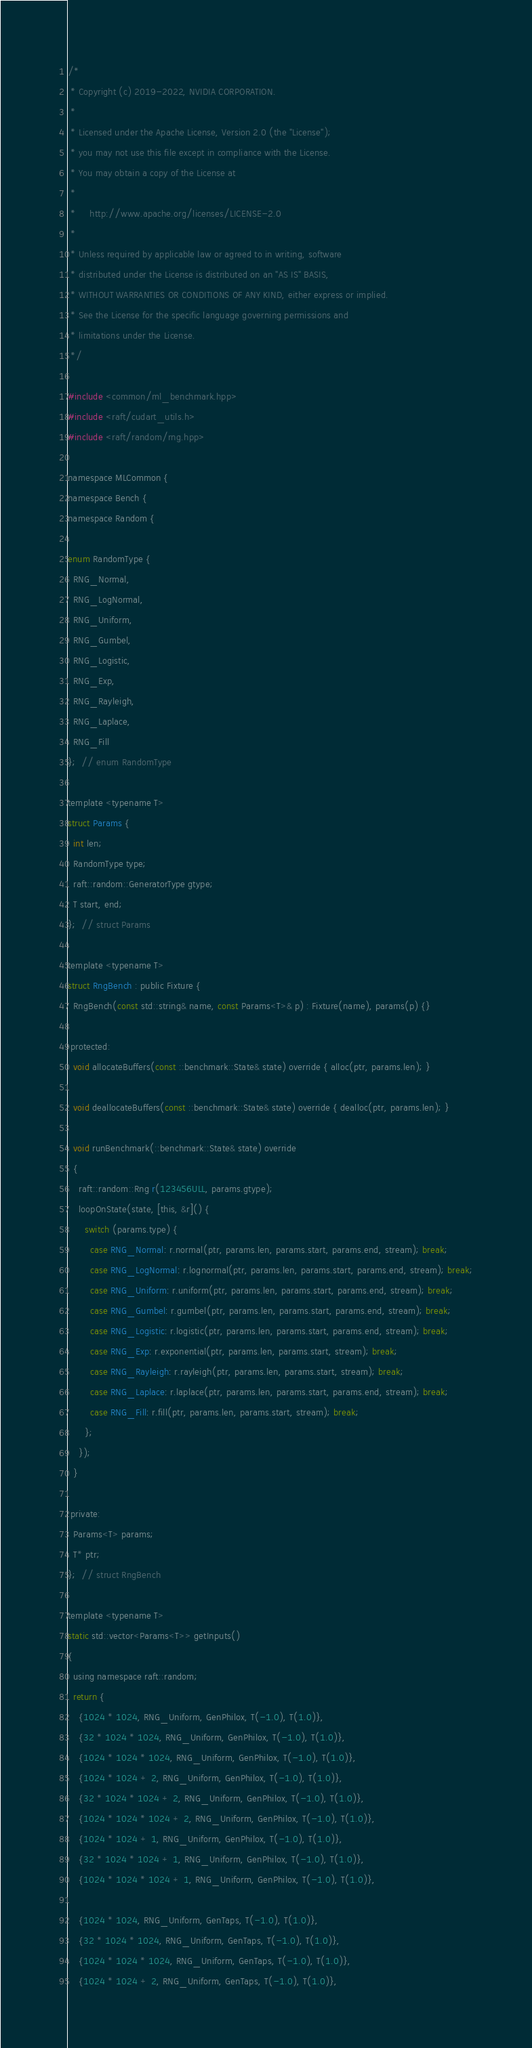<code> <loc_0><loc_0><loc_500><loc_500><_Cuda_>/*
 * Copyright (c) 2019-2022, NVIDIA CORPORATION.
 *
 * Licensed under the Apache License, Version 2.0 (the "License");
 * you may not use this file except in compliance with the License.
 * You may obtain a copy of the License at
 *
 *     http://www.apache.org/licenses/LICENSE-2.0
 *
 * Unless required by applicable law or agreed to in writing, software
 * distributed under the License is distributed on an "AS IS" BASIS,
 * WITHOUT WARRANTIES OR CONDITIONS OF ANY KIND, either express or implied.
 * See the License for the specific language governing permissions and
 * limitations under the License.
 */

#include <common/ml_benchmark.hpp>
#include <raft/cudart_utils.h>
#include <raft/random/rng.hpp>

namespace MLCommon {
namespace Bench {
namespace Random {

enum RandomType {
  RNG_Normal,
  RNG_LogNormal,
  RNG_Uniform,
  RNG_Gumbel,
  RNG_Logistic,
  RNG_Exp,
  RNG_Rayleigh,
  RNG_Laplace,
  RNG_Fill
};  // enum RandomType

template <typename T>
struct Params {
  int len;
  RandomType type;
  raft::random::GeneratorType gtype;
  T start, end;
};  // struct Params

template <typename T>
struct RngBench : public Fixture {
  RngBench(const std::string& name, const Params<T>& p) : Fixture(name), params(p) {}

 protected:
  void allocateBuffers(const ::benchmark::State& state) override { alloc(ptr, params.len); }

  void deallocateBuffers(const ::benchmark::State& state) override { dealloc(ptr, params.len); }

  void runBenchmark(::benchmark::State& state) override
  {
    raft::random::Rng r(123456ULL, params.gtype);
    loopOnState(state, [this, &r]() {
      switch (params.type) {
        case RNG_Normal: r.normal(ptr, params.len, params.start, params.end, stream); break;
        case RNG_LogNormal: r.lognormal(ptr, params.len, params.start, params.end, stream); break;
        case RNG_Uniform: r.uniform(ptr, params.len, params.start, params.end, stream); break;
        case RNG_Gumbel: r.gumbel(ptr, params.len, params.start, params.end, stream); break;
        case RNG_Logistic: r.logistic(ptr, params.len, params.start, params.end, stream); break;
        case RNG_Exp: r.exponential(ptr, params.len, params.start, stream); break;
        case RNG_Rayleigh: r.rayleigh(ptr, params.len, params.start, stream); break;
        case RNG_Laplace: r.laplace(ptr, params.len, params.start, params.end, stream); break;
        case RNG_Fill: r.fill(ptr, params.len, params.start, stream); break;
      };
    });
  }

 private:
  Params<T> params;
  T* ptr;
};  // struct RngBench

template <typename T>
static std::vector<Params<T>> getInputs()
{
  using namespace raft::random;
  return {
    {1024 * 1024, RNG_Uniform, GenPhilox, T(-1.0), T(1.0)},
    {32 * 1024 * 1024, RNG_Uniform, GenPhilox, T(-1.0), T(1.0)},
    {1024 * 1024 * 1024, RNG_Uniform, GenPhilox, T(-1.0), T(1.0)},
    {1024 * 1024 + 2, RNG_Uniform, GenPhilox, T(-1.0), T(1.0)},
    {32 * 1024 * 1024 + 2, RNG_Uniform, GenPhilox, T(-1.0), T(1.0)},
    {1024 * 1024 * 1024 + 2, RNG_Uniform, GenPhilox, T(-1.0), T(1.0)},
    {1024 * 1024 + 1, RNG_Uniform, GenPhilox, T(-1.0), T(1.0)},
    {32 * 1024 * 1024 + 1, RNG_Uniform, GenPhilox, T(-1.0), T(1.0)},
    {1024 * 1024 * 1024 + 1, RNG_Uniform, GenPhilox, T(-1.0), T(1.0)},

    {1024 * 1024, RNG_Uniform, GenTaps, T(-1.0), T(1.0)},
    {32 * 1024 * 1024, RNG_Uniform, GenTaps, T(-1.0), T(1.0)},
    {1024 * 1024 * 1024, RNG_Uniform, GenTaps, T(-1.0), T(1.0)},
    {1024 * 1024 + 2, RNG_Uniform, GenTaps, T(-1.0), T(1.0)},</code> 